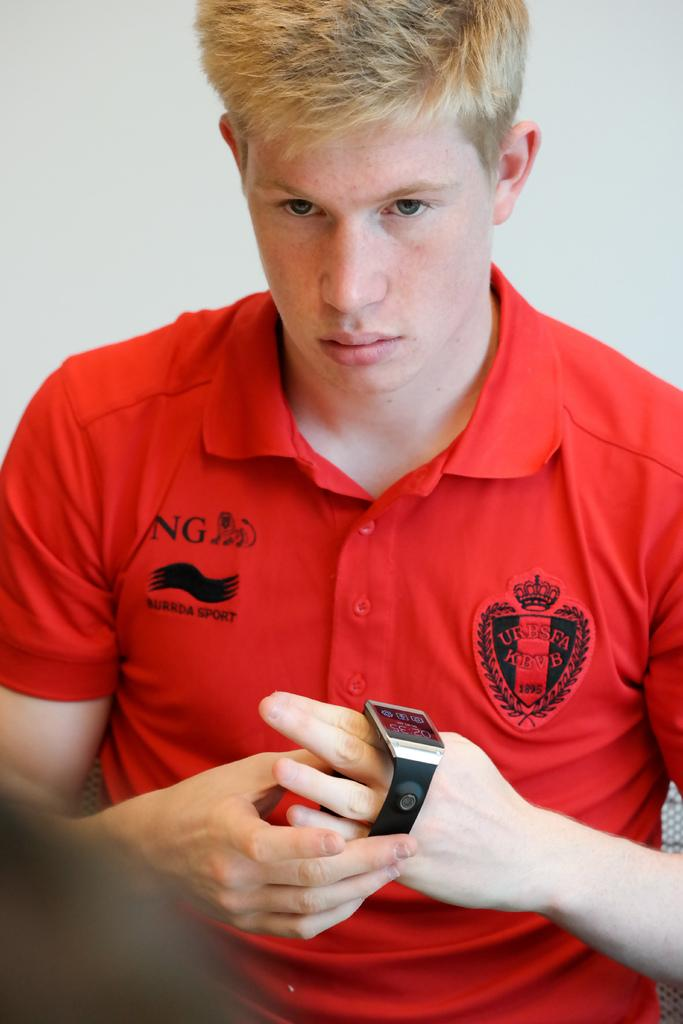Who is the main subject in the image? There is a man in the center of the image. What is the man wearing on his wrist? The man is wearing a watch. What can be seen behind the man in the image? There is a wall in the background of the image. How many goats are visible in the image? There are no goats present in the image. Can you describe the behavior of the ants in the image? There are no ants present in the image. 